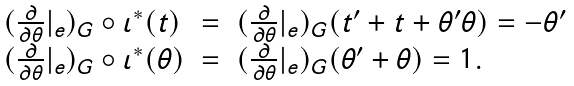Convert formula to latex. <formula><loc_0><loc_0><loc_500><loc_500>\begin{array} { l c l } ( \frac { \partial } { \partial \theta } | _ { e } ) _ { G } \circ \iota ^ { * } ( t ) & = & ( \frac { \partial } { \partial \theta } | _ { e } ) _ { G } ( t ^ { \prime } + t + \theta ^ { \prime } \theta ) = - \theta ^ { \prime } \\ ( \frac { \partial } { \partial \theta } | _ { e } ) _ { G } \circ \iota ^ { * } ( \theta ) & = & ( \frac { \partial } { \partial \theta } | _ { e } ) _ { G } ( \theta ^ { \prime } + \theta ) = 1 . \end{array}</formula> 